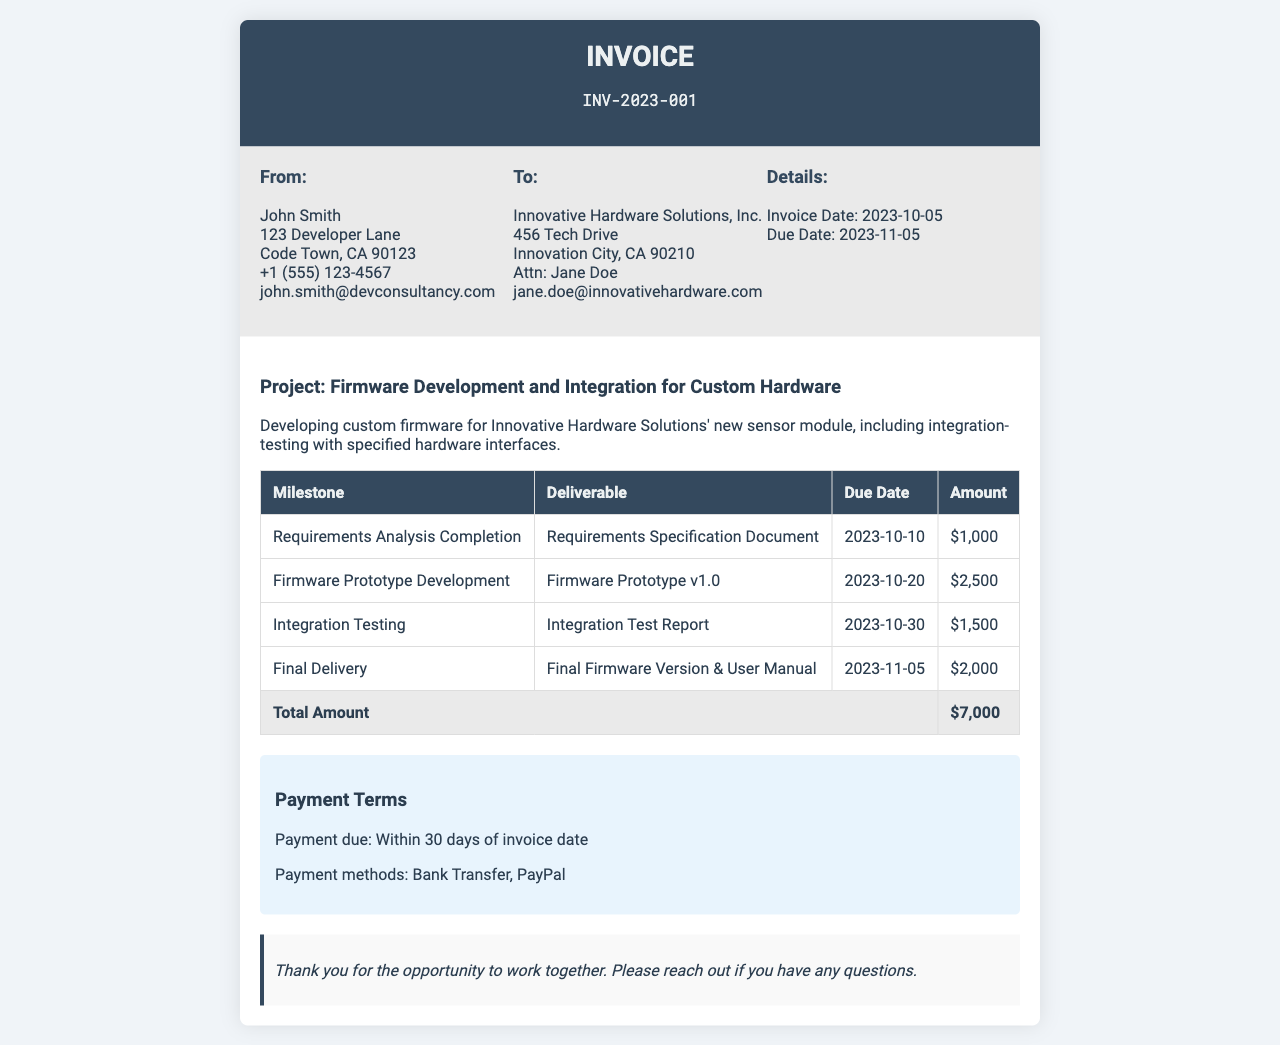what is the invoice number? The invoice number is stated at the top of the document.
Answer: INV-2023-001 who is the recipient of the invoice? The "To" section lists the recipient of the invoice, which is Innovative Hardware Solutions, Inc.
Answer: Innovative Hardware Solutions, Inc what is the total amount due? The total amount due is mentioned in the total row of the table.
Answer: $7,000 when is the final delivery due? The due date for the final delivery is under the corresponding milestone in the table.
Answer: 2023-11-05 what is the payment term? The payment terms are specified in the payment terms section of the invoice.
Answer: Within 30 days of invoice date which milestone has the highest amount? The milestone with the highest amount can be determined from the amounts listed in the table.
Answer: Firmware Prototype Development what deliverable corresponds to the integration testing milestone? The deliverable can be found in the same row as the milestone in the table.
Answer: Integration Test Report who is the contact person for the recipient? The contact person's name is provided in the address of the recipient.
Answer: Jane Doe what is the invoice date? The invoice date is stated in the details section of the document.
Answer: 2023-10-05 